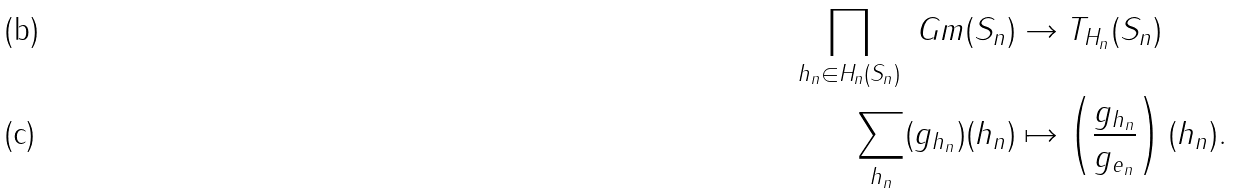<formula> <loc_0><loc_0><loc_500><loc_500>\prod _ { h _ { n } \in H _ { n } ( S _ { n } ) } \ G m ( S _ { n } ) & \to T _ { H _ { n } } ( S _ { n } ) \\ \sum _ { h _ { n } } ( g _ { h _ { n } } ) ( h _ { n } ) & \mapsto \left ( \frac { g _ { h _ { n } } } { g _ { e _ { n } } } \right ) ( h _ { n } ) .</formula> 